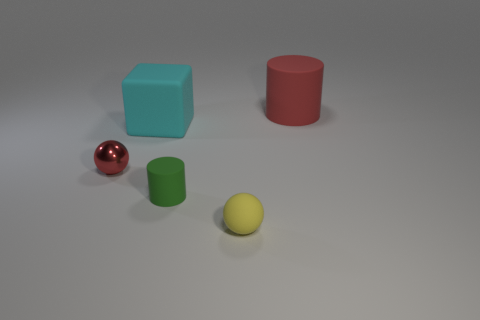What size is the cylinder in front of the small red ball?
Keep it short and to the point. Small. There is a red object on the left side of the cylinder that is behind the small metal object; what number of big cyan things are behind it?
Make the answer very short. 1. Are there any things left of the small cylinder?
Your response must be concise. Yes. How many other things are the same size as the green cylinder?
Provide a short and direct response. 2. What material is the object that is in front of the cyan thing and left of the green matte cylinder?
Make the answer very short. Metal. There is a large matte object that is in front of the big red object; is it the same shape as the red object that is behind the small red metal sphere?
Provide a short and direct response. No. Is there anything else that has the same material as the tiny cylinder?
Give a very brief answer. Yes. There is a red thing that is in front of the large object on the right side of the sphere to the right of the metal sphere; what is its shape?
Your answer should be compact. Sphere. How many other things are the same shape as the shiny object?
Keep it short and to the point. 1. There is a metallic thing that is the same size as the green matte thing; what color is it?
Your answer should be very brief. Red. 